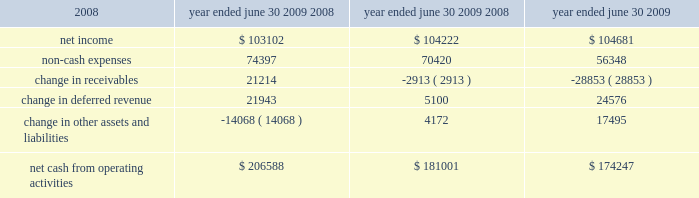26 | 2009 annual report in fiscal 2008 , revenues in the credit union systems and services business segment increased 14% ( 14 % ) from fiscal 2007 .
All revenue components within the segment experienced growth during fiscal 2008 .
License revenue generated the largest dollar growth in revenue as episys ae , our flagship core processing system aimed at larger credit unions , experienced strong sales throughout the year .
Support and service revenue , which is the largest component of total revenues for the credit union segment , experienced 34 percent growth in eft support and 10 percent growth in in-house support .
Gross profit in this business segment increased $ 9344 in fiscal 2008 compared to fiscal 2007 , due primarily to the increase in license revenue , which carries the highest margins .
Liquidity and capital resources we have historically generated positive cash flow from operations and have generally used funds generated from operations and short-term borrowings on our revolving credit facility to meet capital requirements .
We expect this trend to continue in the future .
The company 2019s cash and cash equivalents increased to $ 118251 at june 30 , 2009 from $ 65565 at june 30 , 2008 .
The table summarizes net cash from operating activities in the statement of cash flows : 2009 2008 2007 .
Year ended june 30 , cash provided by operations increased $ 25587 to $ 206588 for the fiscal year ended june 30 , 2009 as compared to $ 181001 for the fiscal year ended june 30 , 2008 .
This increase is primarily attributable to a decrease in receivables compared to the same period a year ago of $ 21214 .
This decrease is largely the result of fiscal 2010 annual software maintenance billings being provided to customers earlier than in the prior year , which allowed more cash to be collected before the end of the fiscal year than in previous years .
Further , we collected more cash overall related to revenues that will be recognized in subsequent periods in the current year than in fiscal 2008 .
Cash used in investing activities for the fiscal year ended june 2009 was $ 59227 and includes $ 3027 in contingent consideration paid on prior years 2019 acquisitions .
Cash used in investing activities for the fiscal year ended june 2008 was $ 102148 and includes payments for acquisitions of $ 48109 , plus $ 1215 in contingent consideration paid on prior years 2019 acquisitions .
Capital expenditures for fiscal 2009 were $ 31562 compared to $ 31105 for fiscal 2008 .
Cash used for software development in fiscal 2009 was $ 24684 compared to $ 23736 during the prior year .
Net cash used in financing activities for the current fiscal year was $ 94675 and includes the repurchase of 3106 shares of our common stock for $ 58405 , the payment of dividends of $ 26903 and $ 13489 net repayment on our revolving credit facilities .
Cash used in financing activities was partially offset by proceeds of $ 3773 from the exercise of stock options and the sale of common stock ( through the employee stock purchase plan ) and $ 348 excess tax benefits from stock option exercises .
During fiscal 2008 , net cash used in financing activities for the fiscal year was $ 101905 and includes the repurchase of 4200 shares of our common stock for $ 100996 , the payment of dividends of $ 24683 and $ 429 net repayment on our revolving credit facilities .
Cash used in financing activities was partially offset by proceeds of $ 20394 from the exercise of stock options and the sale of common stock and $ 3809 excess tax benefits from stock option exercises .
Beginning during fiscal 2008 , us financial markets and many of the largest us financial institutions have been shaken by negative developments in the home mortgage industry and the mortgage markets , and particularly the markets for subprime mortgage-backed securities .
Since that time , these and other such developments have resulted in a broad , global economic downturn .
While we , as is the case with most companies , have experienced the effects of this downturn , we have not experienced any significant issues with our current collection efforts , and we believe that any future impact to our liquidity will be minimized by cash generated by recurring sources of revenue and due to our access to available lines of credit. .
What was the percentage change in the net cash from operating activities from 2008 to 2009? 
Computations: ((206588 - 181001) / 181001)
Answer: 0.14136. 